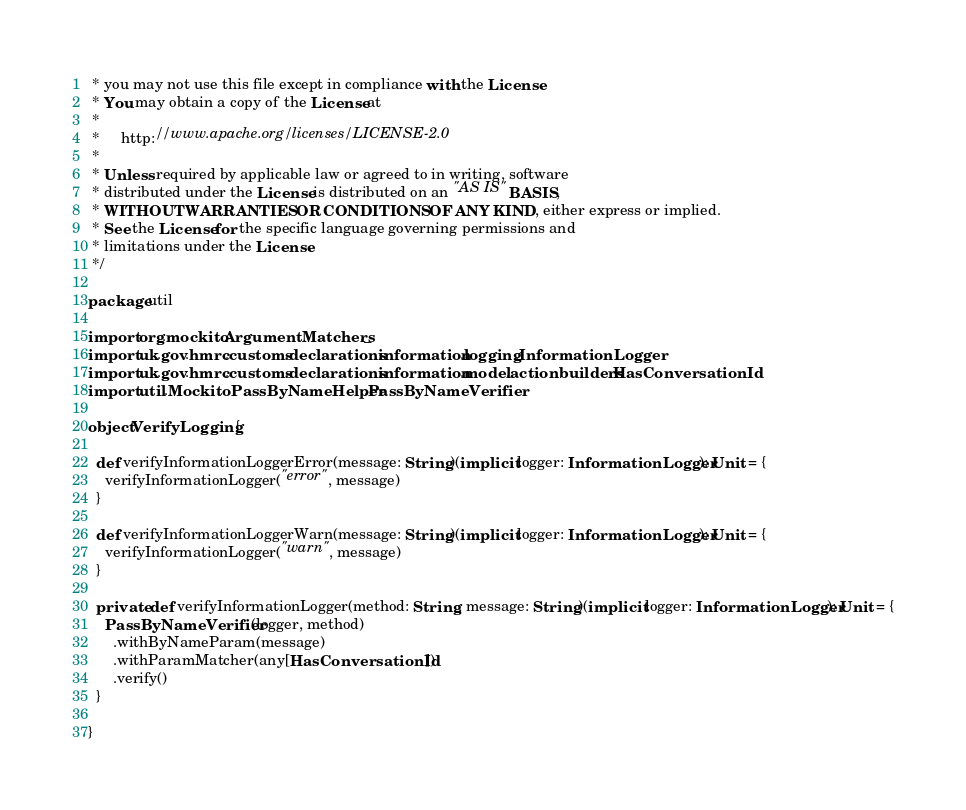Convert code to text. <code><loc_0><loc_0><loc_500><loc_500><_Scala_> * you may not use this file except in compliance with the License.
 * You may obtain a copy of the License at
 *
 *     http://www.apache.org/licenses/LICENSE-2.0
 *
 * Unless required by applicable law or agreed to in writing, software
 * distributed under the License is distributed on an "AS IS" BASIS,
 * WITHOUT WARRANTIES OR CONDITIONS OF ANY KIND, either express or implied.
 * See the License for the specific language governing permissions and
 * limitations under the License.
 */

package util

import org.mockito.ArgumentMatchers._
import uk.gov.hmrc.customs.declarations.information.logging.InformationLogger
import uk.gov.hmrc.customs.declarations.information.model.actionbuilders.HasConversationId
import util.MockitoPassByNameHelper.PassByNameVerifier

object VerifyLogging {

  def verifyInformationLoggerError(message: String)(implicit logger: InformationLogger): Unit = {
    verifyInformationLogger("error", message)
  }

  def verifyInformationLoggerWarn(message: String)(implicit logger: InformationLogger): Unit = {
    verifyInformationLogger("warn", message)
  }

  private def verifyInformationLogger(method: String, message: String)(implicit logger: InformationLogger): Unit = {
    PassByNameVerifier(logger, method)
      .withByNameParam(message)
      .withParamMatcher(any[HasConversationId])
      .verify()
  }

}
</code> 